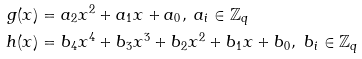<formula> <loc_0><loc_0><loc_500><loc_500>g ( x ) & = a _ { 2 } x ^ { 2 } + a _ { 1 } x + a _ { 0 } , \ a _ { i } \in \mathbb { Z } _ { q } \\ h ( x ) & = b _ { 4 } x ^ { 4 } + b _ { 3 } x ^ { 3 } + b _ { 2 } x ^ { 2 } + b _ { 1 } x + b _ { 0 } , \ b _ { i } \in \mathbb { Z } _ { q }</formula> 